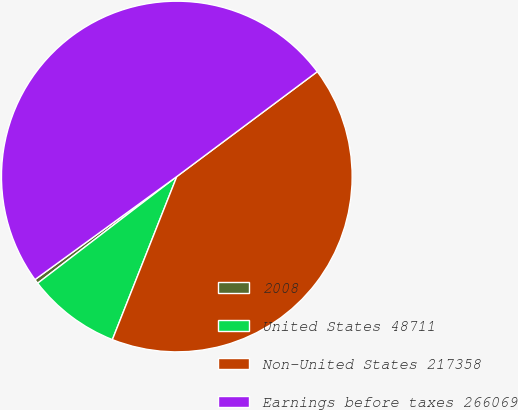Convert chart. <chart><loc_0><loc_0><loc_500><loc_500><pie_chart><fcel>2008<fcel>United States 48711<fcel>Non-United States 217358<fcel>Earnings before taxes 266069<nl><fcel>0.41%<fcel>8.6%<fcel>41.19%<fcel>49.79%<nl></chart> 